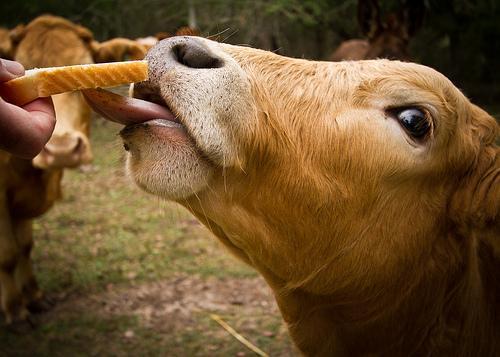How many eyes are seen in the picture?
Give a very brief answer. 1. How many human hands?
Give a very brief answer. 1. How many cows are visible in this photo?
Give a very brief answer. 2. 